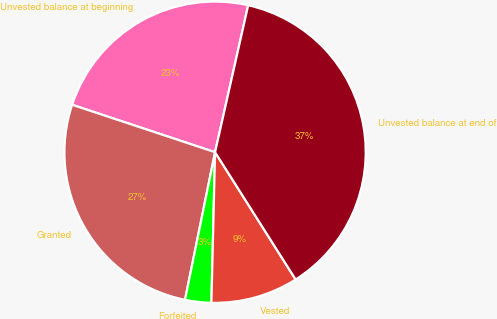Convert chart to OTSL. <chart><loc_0><loc_0><loc_500><loc_500><pie_chart><fcel>Unvested balance at beginning<fcel>Granted<fcel>Forfeited<fcel>Vested<fcel>Unvested balance at end of<nl><fcel>23.43%<fcel>26.9%<fcel>2.81%<fcel>9.37%<fcel>37.49%<nl></chart> 